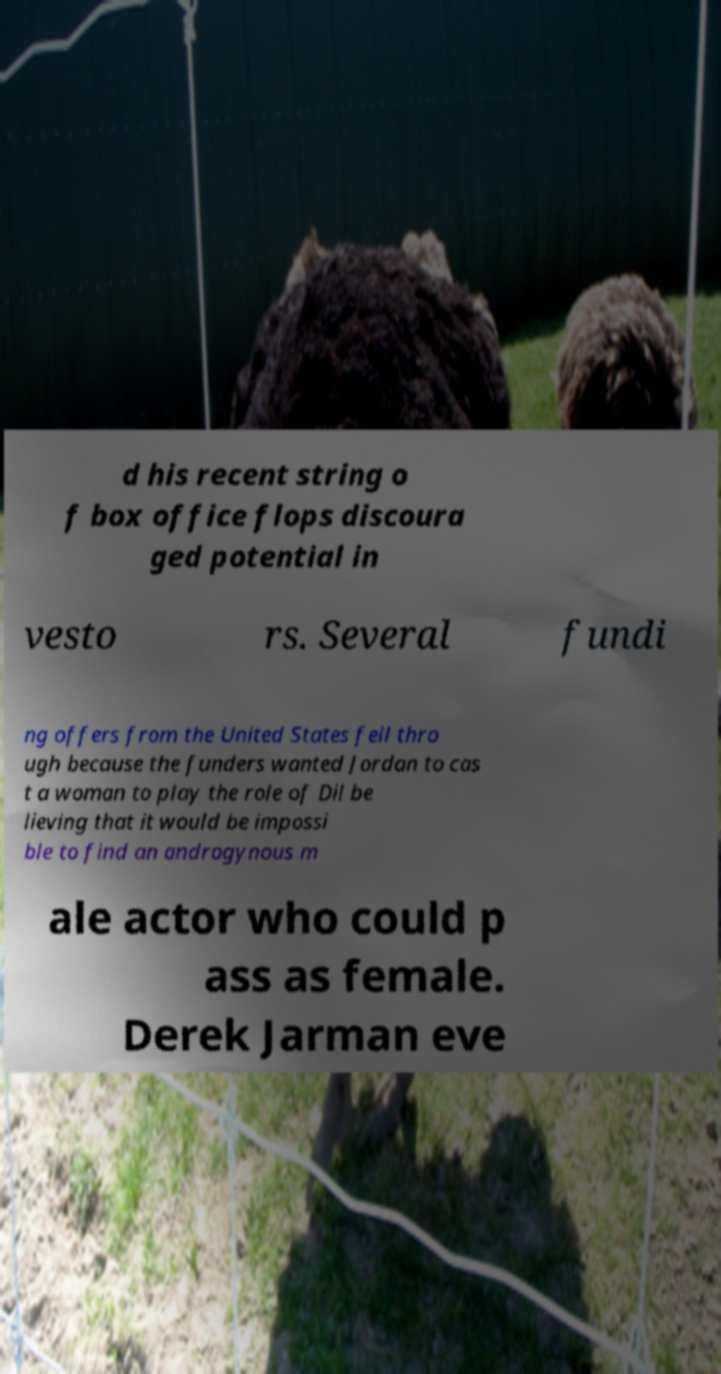Please read and relay the text visible in this image. What does it say? d his recent string o f box office flops discoura ged potential in vesto rs. Several fundi ng offers from the United States fell thro ugh because the funders wanted Jordan to cas t a woman to play the role of Dil be lieving that it would be impossi ble to find an androgynous m ale actor who could p ass as female. Derek Jarman eve 